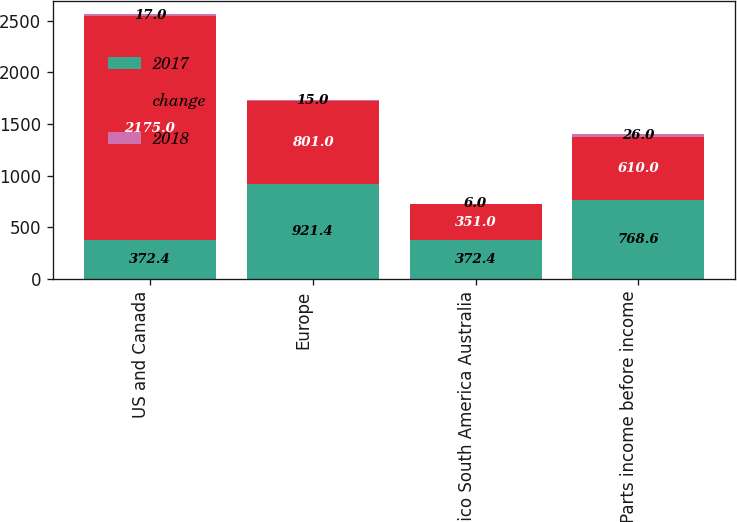Convert chart. <chart><loc_0><loc_0><loc_500><loc_500><stacked_bar_chart><ecel><fcel>US and Canada<fcel>Europe<fcel>Mexico South America Australia<fcel>Parts income before income<nl><fcel>2017<fcel>372.4<fcel>921.4<fcel>372.4<fcel>768.6<nl><fcel>change<fcel>2175<fcel>801<fcel>351<fcel>610<nl><fcel>2018<fcel>17<fcel>15<fcel>6<fcel>26<nl></chart> 